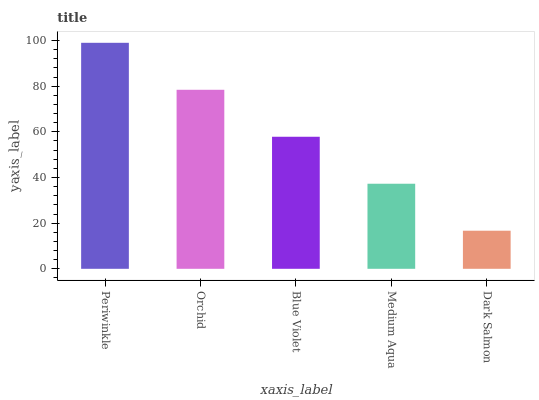Is Orchid the minimum?
Answer yes or no. No. Is Orchid the maximum?
Answer yes or no. No. Is Periwinkle greater than Orchid?
Answer yes or no. Yes. Is Orchid less than Periwinkle?
Answer yes or no. Yes. Is Orchid greater than Periwinkle?
Answer yes or no. No. Is Periwinkle less than Orchid?
Answer yes or no. No. Is Blue Violet the high median?
Answer yes or no. Yes. Is Blue Violet the low median?
Answer yes or no. Yes. Is Periwinkle the high median?
Answer yes or no. No. Is Orchid the low median?
Answer yes or no. No. 